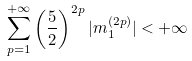Convert formula to latex. <formula><loc_0><loc_0><loc_500><loc_500>\sum _ { p = 1 } ^ { + \infty } \left ( \frac { 5 } { 2 } \right ) ^ { 2 p } | m _ { 1 } ^ { ( 2 p ) } | < + \infty</formula> 